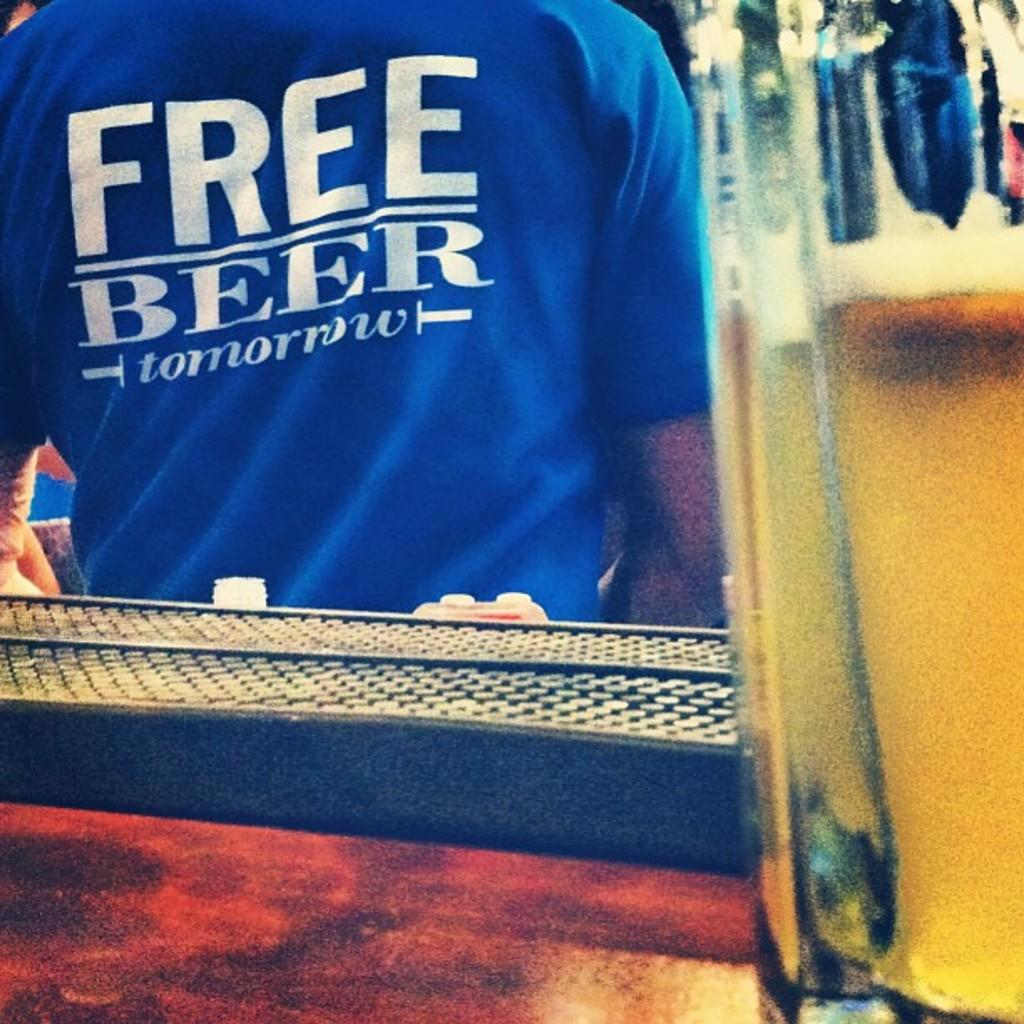<image>
Share a concise interpretation of the image provided. A person is wearing a shirt that says "free beer tomorrow". 